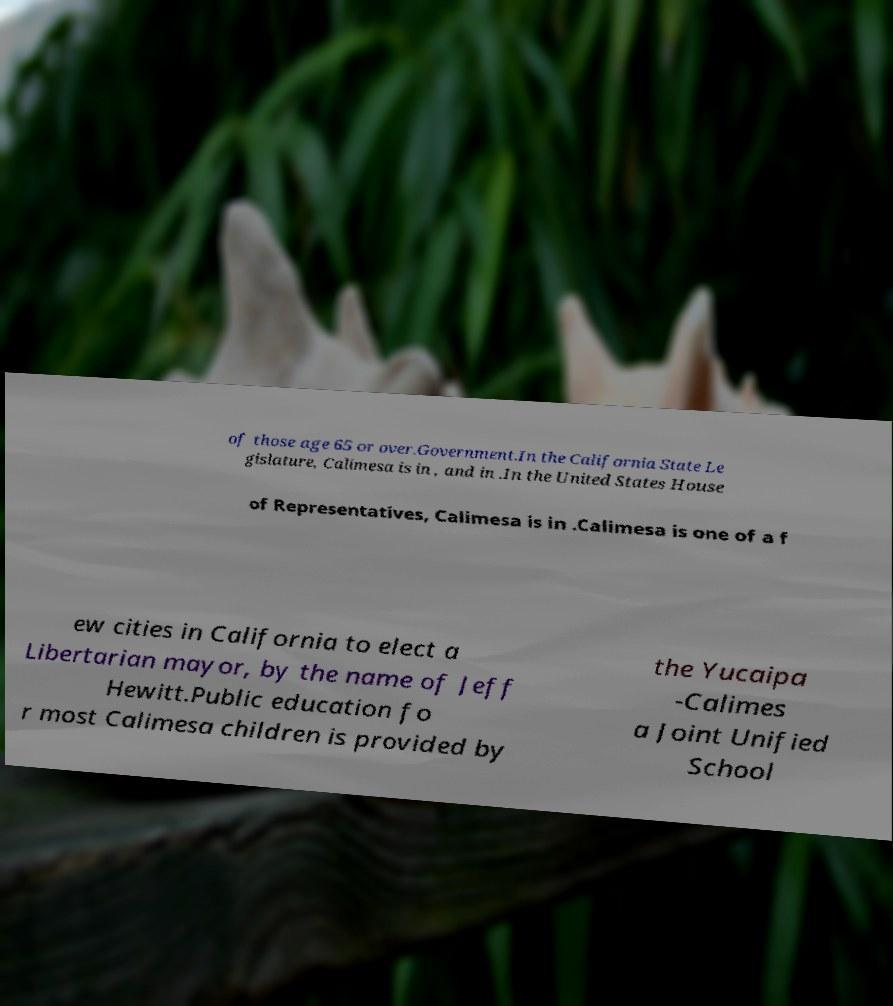Could you extract and type out the text from this image? of those age 65 or over.Government.In the California State Le gislature, Calimesa is in , and in .In the United States House of Representatives, Calimesa is in .Calimesa is one of a f ew cities in California to elect a Libertarian mayor, by the name of Jeff Hewitt.Public education fo r most Calimesa children is provided by the Yucaipa -Calimes a Joint Unified School 